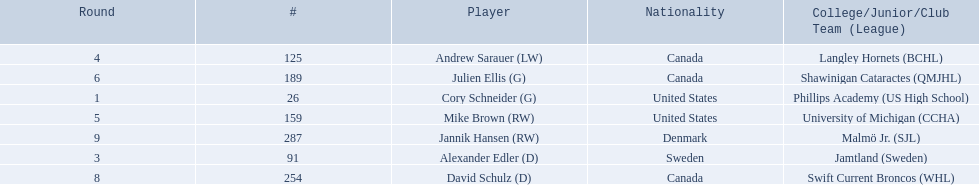What are the names of the colleges and jr leagues the players attended? Phillips Academy (US High School), Jamtland (Sweden), Langley Hornets (BCHL), University of Michigan (CCHA), Shawinigan Cataractes (QMJHL), Swift Current Broncos (WHL), Malmö Jr. (SJL). Which player played for the langley hornets? Andrew Sarauer (LW). 